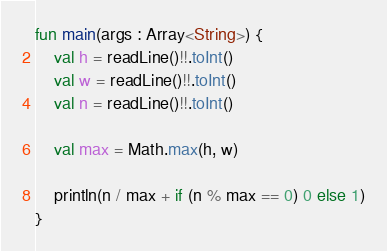Convert code to text. <code><loc_0><loc_0><loc_500><loc_500><_Kotlin_>fun main(args : Array<String>) {
    val h = readLine()!!.toInt()
    val w = readLine()!!.toInt()
    val n = readLine()!!.toInt()

    val max = Math.max(h, w)

    println(n / max + if (n % max == 0) 0 else 1)
}</code> 